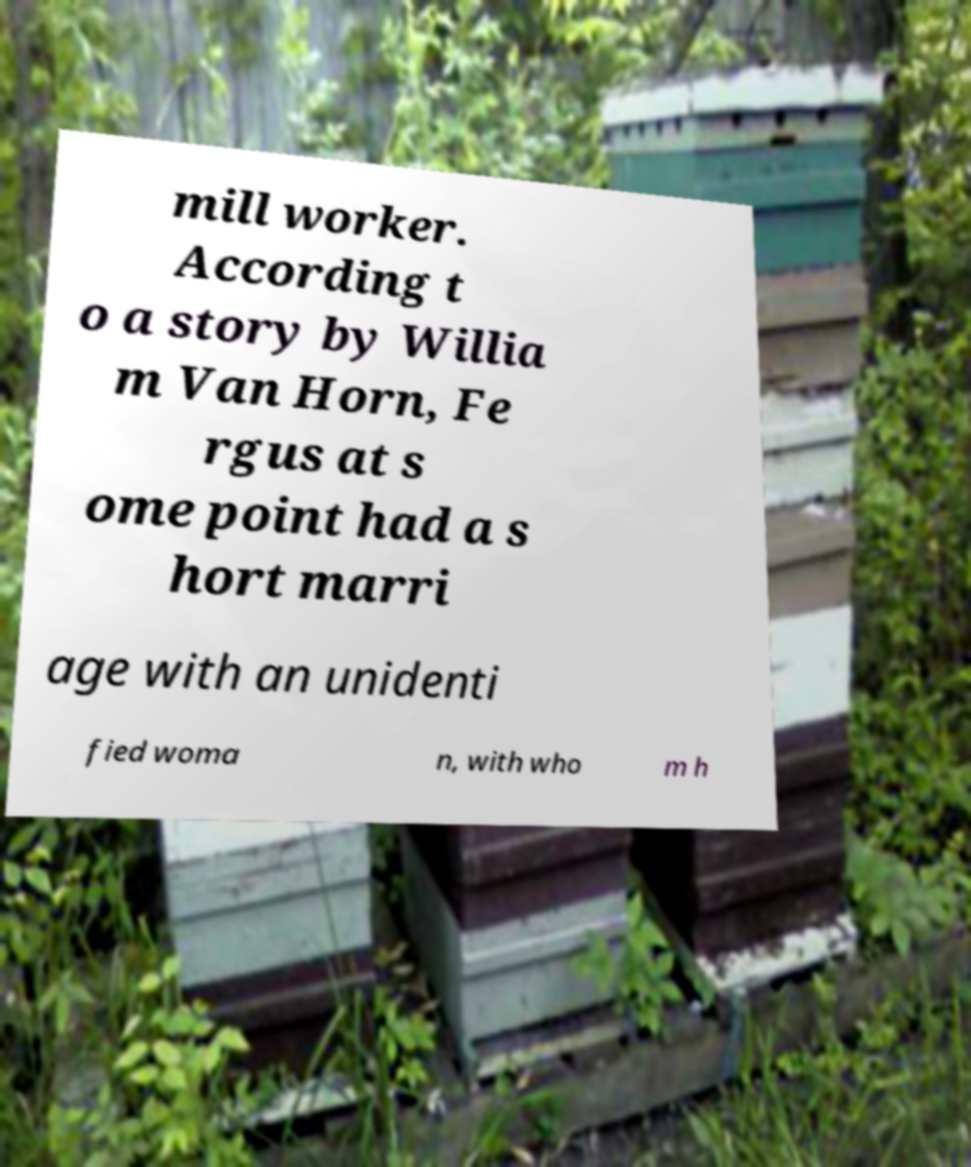For documentation purposes, I need the text within this image transcribed. Could you provide that? mill worker. According t o a story by Willia m Van Horn, Fe rgus at s ome point had a s hort marri age with an unidenti fied woma n, with who m h 